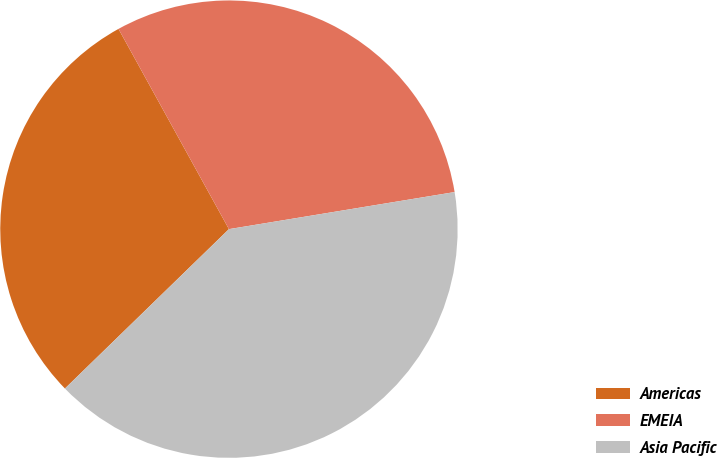<chart> <loc_0><loc_0><loc_500><loc_500><pie_chart><fcel>Americas<fcel>EMEIA<fcel>Asia Pacific<nl><fcel>29.25%<fcel>30.43%<fcel>40.32%<nl></chart> 